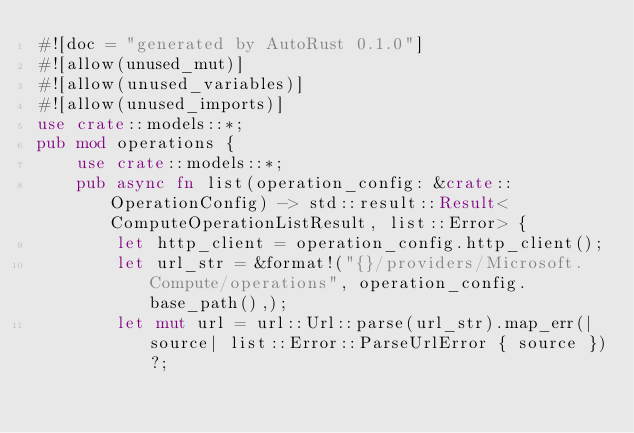<code> <loc_0><loc_0><loc_500><loc_500><_Rust_>#![doc = "generated by AutoRust 0.1.0"]
#![allow(unused_mut)]
#![allow(unused_variables)]
#![allow(unused_imports)]
use crate::models::*;
pub mod operations {
    use crate::models::*;
    pub async fn list(operation_config: &crate::OperationConfig) -> std::result::Result<ComputeOperationListResult, list::Error> {
        let http_client = operation_config.http_client();
        let url_str = &format!("{}/providers/Microsoft.Compute/operations", operation_config.base_path(),);
        let mut url = url::Url::parse(url_str).map_err(|source| list::Error::ParseUrlError { source })?;</code> 